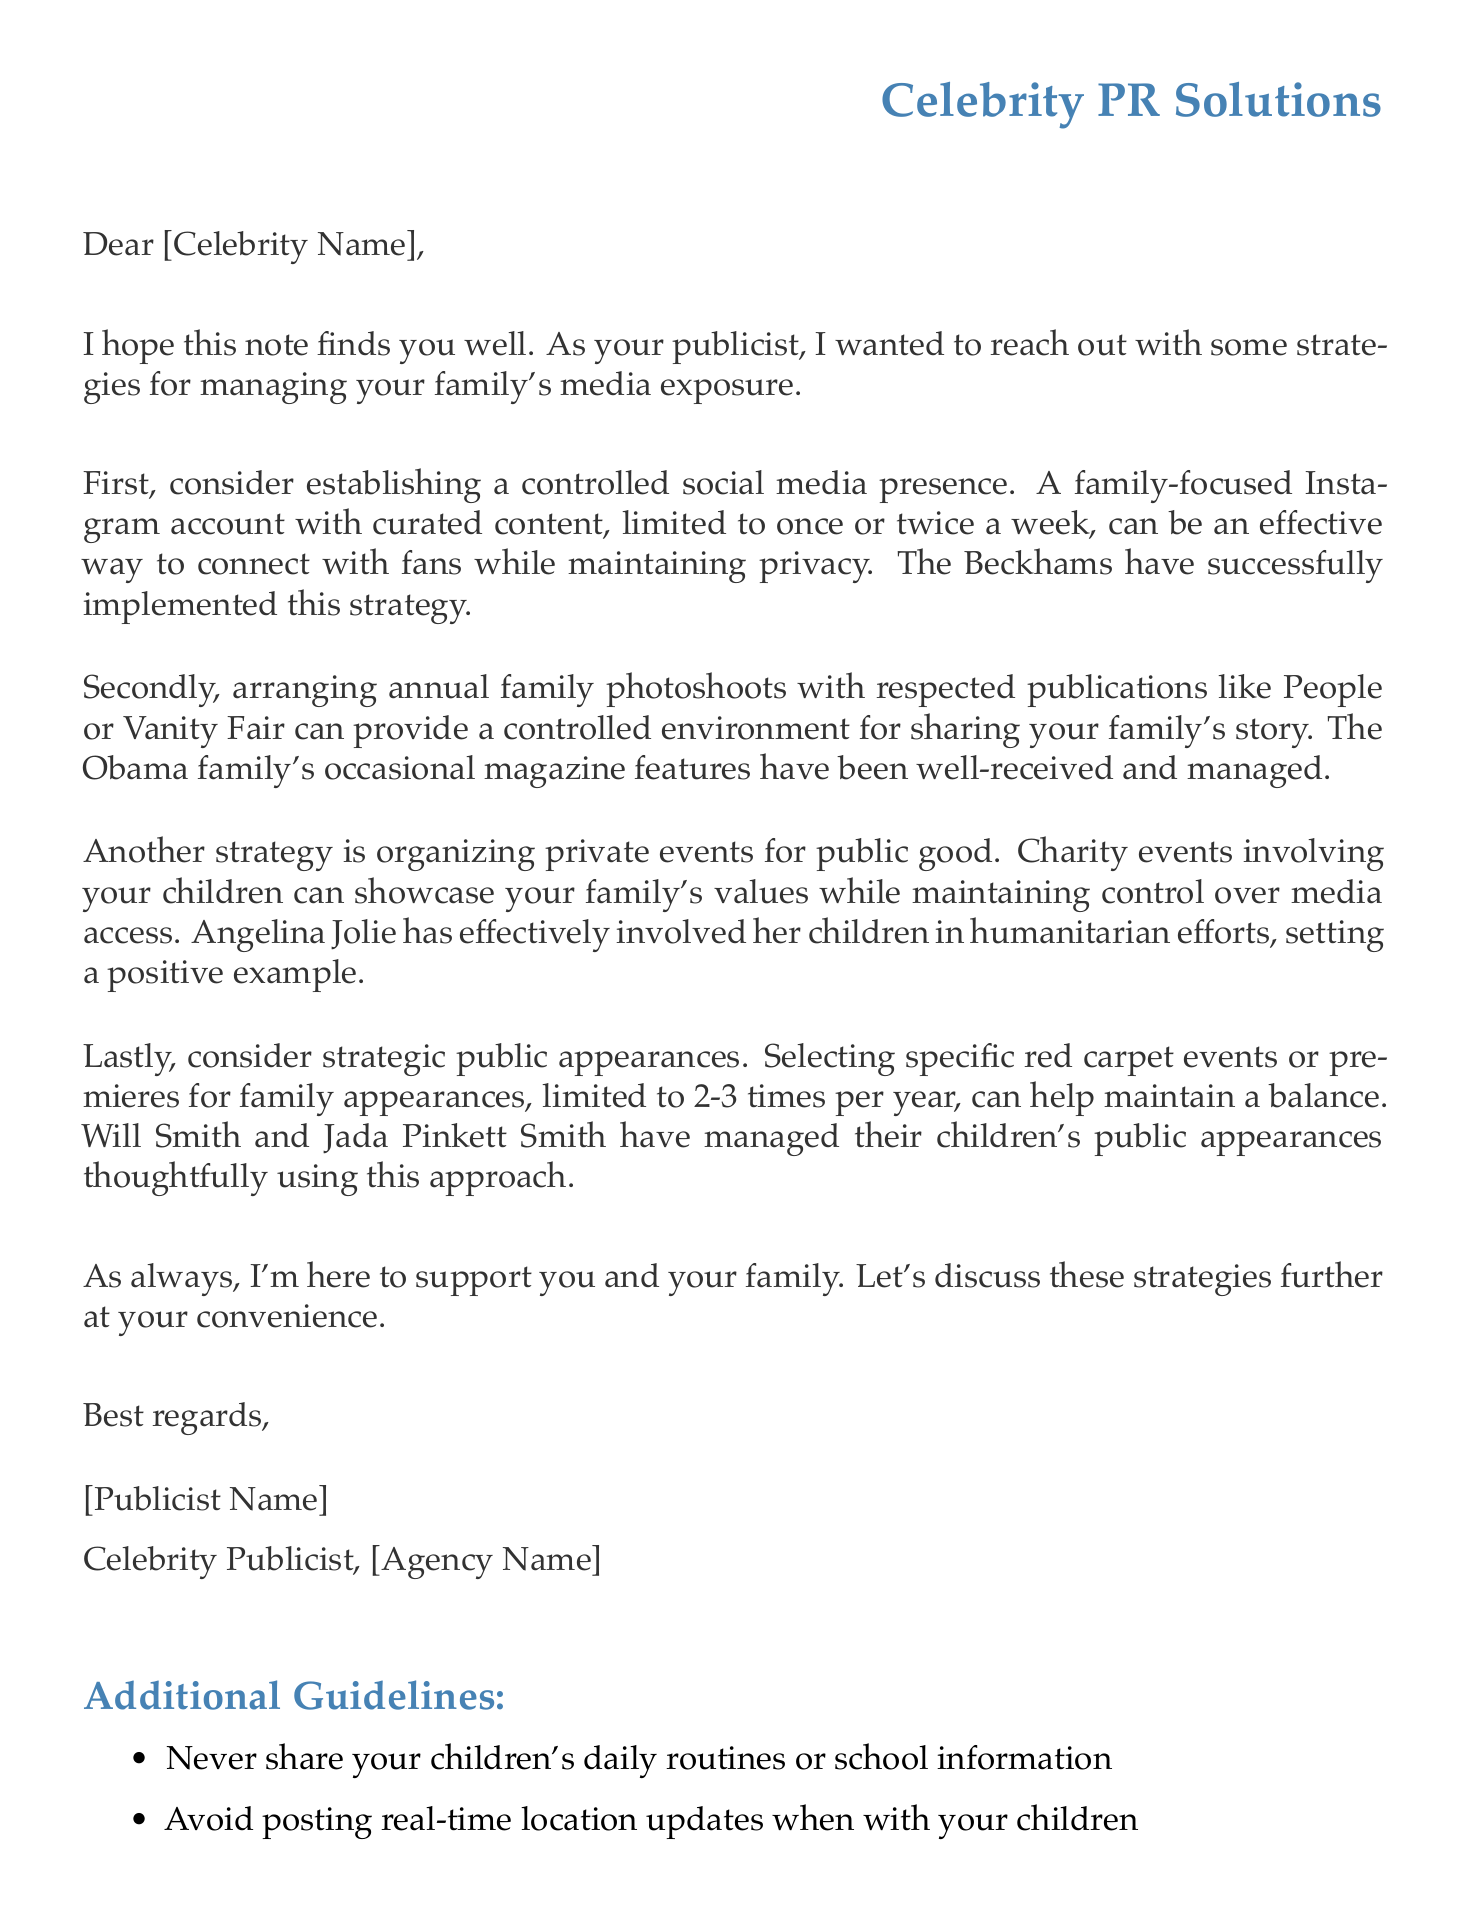What is the sender's title? The sender is identified as a publicist for the celebrity.
Answer: Celebrity Publicist How many times per year is it suggested the family appear at public events? The letter states that family appearances at public events should be limited to 2-3 times per year.
Answer: 2-3 times What social media strategy is recommended? A family-focused Instagram account with curated content is suggested as a media strategy.
Answer: Controlled Social Media Presence Which famous family is mentioned as an example of controlled social media presence? The letter uses the Beckhams as an example of maintaining a balanced family presence on social media.
Answer: The Beckhams What legal consideration is mentioned regarding harassment of children? The document references California's SB 606 regarding penalties for harassment.
Answer: California's SB 606 What is suggested for working with photographers? The document advises working with trusted photographers for family portraits.
Answer: Trusted photographers What type of public event is recommended involving the children? Organizing charity events that involve the children is suggested.
Answer: Charity events What support network is mentioned for celebrity parents? The document refers to a support group called Hollywood Moms and Dads.
Answer: Hollywood Moms and Dads 